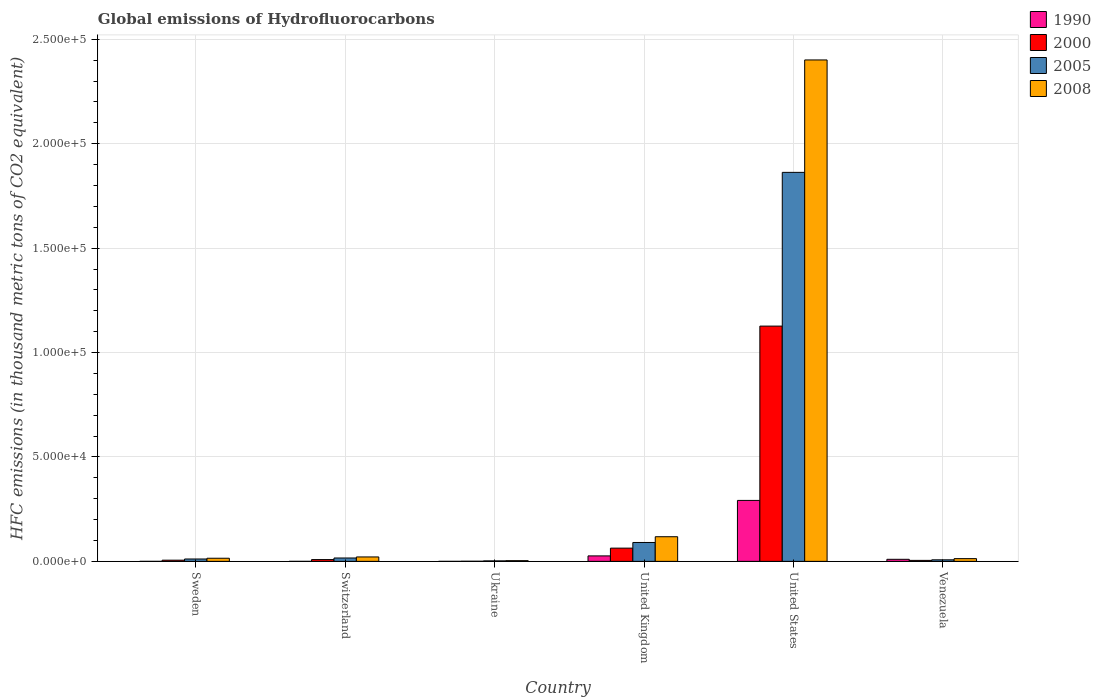How many different coloured bars are there?
Provide a short and direct response. 4. How many bars are there on the 3rd tick from the left?
Make the answer very short. 4. What is the global emissions of Hydrofluorocarbons in 2000 in United Kingdom?
Keep it short and to the point. 6332.5. Across all countries, what is the maximum global emissions of Hydrofluorocarbons in 2005?
Offer a very short reply. 1.86e+05. Across all countries, what is the minimum global emissions of Hydrofluorocarbons in 2008?
Offer a terse response. 333.5. In which country was the global emissions of Hydrofluorocarbons in 2000 minimum?
Offer a terse response. Ukraine. What is the total global emissions of Hydrofluorocarbons in 2008 in the graph?
Your response must be concise. 2.57e+05. What is the difference between the global emissions of Hydrofluorocarbons in 2005 in Ukraine and that in United States?
Make the answer very short. -1.86e+05. What is the difference between the global emissions of Hydrofluorocarbons in 2005 in United States and the global emissions of Hydrofluorocarbons in 1990 in Sweden?
Your response must be concise. 1.86e+05. What is the average global emissions of Hydrofluorocarbons in 2000 per country?
Your answer should be compact. 2.02e+04. What is the difference between the global emissions of Hydrofluorocarbons of/in 2000 and global emissions of Hydrofluorocarbons of/in 2005 in Ukraine?
Your answer should be compact. -172.5. What is the ratio of the global emissions of Hydrofluorocarbons in 2008 in Sweden to that in Switzerland?
Offer a terse response. 0.71. Is the global emissions of Hydrofluorocarbons in 2008 in Switzerland less than that in United Kingdom?
Your answer should be compact. Yes. Is the difference between the global emissions of Hydrofluorocarbons in 2000 in Switzerland and Ukraine greater than the difference between the global emissions of Hydrofluorocarbons in 2005 in Switzerland and Ukraine?
Make the answer very short. No. What is the difference between the highest and the second highest global emissions of Hydrofluorocarbons in 2008?
Your response must be concise. 9679.6. What is the difference between the highest and the lowest global emissions of Hydrofluorocarbons in 1990?
Your answer should be compact. 2.92e+04. In how many countries, is the global emissions of Hydrofluorocarbons in 1990 greater than the average global emissions of Hydrofluorocarbons in 1990 taken over all countries?
Your answer should be very brief. 1. What does the 2nd bar from the left in United Kingdom represents?
Provide a succinct answer. 2000. Is it the case that in every country, the sum of the global emissions of Hydrofluorocarbons in 2000 and global emissions of Hydrofluorocarbons in 2008 is greater than the global emissions of Hydrofluorocarbons in 2005?
Offer a very short reply. Yes. How many countries are there in the graph?
Give a very brief answer. 6. Are the values on the major ticks of Y-axis written in scientific E-notation?
Provide a succinct answer. Yes. Does the graph contain grids?
Offer a very short reply. Yes. Where does the legend appear in the graph?
Offer a very short reply. Top right. How many legend labels are there?
Ensure brevity in your answer.  4. What is the title of the graph?
Provide a succinct answer. Global emissions of Hydrofluorocarbons. What is the label or title of the X-axis?
Ensure brevity in your answer.  Country. What is the label or title of the Y-axis?
Your response must be concise. HFC emissions (in thousand metric tons of CO2 equivalent). What is the HFC emissions (in thousand metric tons of CO2 equivalent) in 2000 in Sweden?
Provide a succinct answer. 568.8. What is the HFC emissions (in thousand metric tons of CO2 equivalent) of 2005 in Sweden?
Offer a terse response. 1131.9. What is the HFC emissions (in thousand metric tons of CO2 equivalent) in 2008 in Sweden?
Your answer should be compact. 1498. What is the HFC emissions (in thousand metric tons of CO2 equivalent) of 2000 in Switzerland?
Provide a succinct answer. 848.2. What is the HFC emissions (in thousand metric tons of CO2 equivalent) of 2005 in Switzerland?
Keep it short and to the point. 1613.8. What is the HFC emissions (in thousand metric tons of CO2 equivalent) in 2008 in Switzerland?
Give a very brief answer. 2116.4. What is the HFC emissions (in thousand metric tons of CO2 equivalent) in 1990 in Ukraine?
Your answer should be compact. 0.1. What is the HFC emissions (in thousand metric tons of CO2 equivalent) in 2000 in Ukraine?
Your response must be concise. 54.7. What is the HFC emissions (in thousand metric tons of CO2 equivalent) in 2005 in Ukraine?
Give a very brief answer. 227.2. What is the HFC emissions (in thousand metric tons of CO2 equivalent) in 2008 in Ukraine?
Ensure brevity in your answer.  333.5. What is the HFC emissions (in thousand metric tons of CO2 equivalent) of 1990 in United Kingdom?
Your answer should be compact. 2617.8. What is the HFC emissions (in thousand metric tons of CO2 equivalent) of 2000 in United Kingdom?
Make the answer very short. 6332.5. What is the HFC emissions (in thousand metric tons of CO2 equivalent) of 2005 in United Kingdom?
Offer a very short reply. 9043.4. What is the HFC emissions (in thousand metric tons of CO2 equivalent) in 2008 in United Kingdom?
Provide a short and direct response. 1.18e+04. What is the HFC emissions (in thousand metric tons of CO2 equivalent) in 1990 in United States?
Offer a terse response. 2.92e+04. What is the HFC emissions (in thousand metric tons of CO2 equivalent) of 2000 in United States?
Provide a short and direct response. 1.13e+05. What is the HFC emissions (in thousand metric tons of CO2 equivalent) in 2005 in United States?
Your answer should be very brief. 1.86e+05. What is the HFC emissions (in thousand metric tons of CO2 equivalent) of 2008 in United States?
Your answer should be very brief. 2.40e+05. What is the HFC emissions (in thousand metric tons of CO2 equivalent) of 1990 in Venezuela?
Offer a very short reply. 989.6. What is the HFC emissions (in thousand metric tons of CO2 equivalent) of 2000 in Venezuela?
Provide a succinct answer. 468.5. What is the HFC emissions (in thousand metric tons of CO2 equivalent) in 2005 in Venezuela?
Provide a short and direct response. 738.4. What is the HFC emissions (in thousand metric tons of CO2 equivalent) of 2008 in Venezuela?
Keep it short and to the point. 1307.1. Across all countries, what is the maximum HFC emissions (in thousand metric tons of CO2 equivalent) of 1990?
Keep it short and to the point. 2.92e+04. Across all countries, what is the maximum HFC emissions (in thousand metric tons of CO2 equivalent) in 2000?
Offer a terse response. 1.13e+05. Across all countries, what is the maximum HFC emissions (in thousand metric tons of CO2 equivalent) in 2005?
Your answer should be very brief. 1.86e+05. Across all countries, what is the maximum HFC emissions (in thousand metric tons of CO2 equivalent) in 2008?
Your answer should be very brief. 2.40e+05. Across all countries, what is the minimum HFC emissions (in thousand metric tons of CO2 equivalent) of 2000?
Ensure brevity in your answer.  54.7. Across all countries, what is the minimum HFC emissions (in thousand metric tons of CO2 equivalent) of 2005?
Provide a short and direct response. 227.2. Across all countries, what is the minimum HFC emissions (in thousand metric tons of CO2 equivalent) in 2008?
Offer a terse response. 333.5. What is the total HFC emissions (in thousand metric tons of CO2 equivalent) in 1990 in the graph?
Keep it short and to the point. 3.28e+04. What is the total HFC emissions (in thousand metric tons of CO2 equivalent) in 2000 in the graph?
Keep it short and to the point. 1.21e+05. What is the total HFC emissions (in thousand metric tons of CO2 equivalent) in 2005 in the graph?
Ensure brevity in your answer.  1.99e+05. What is the total HFC emissions (in thousand metric tons of CO2 equivalent) of 2008 in the graph?
Your answer should be compact. 2.57e+05. What is the difference between the HFC emissions (in thousand metric tons of CO2 equivalent) in 1990 in Sweden and that in Switzerland?
Keep it short and to the point. -0.1. What is the difference between the HFC emissions (in thousand metric tons of CO2 equivalent) in 2000 in Sweden and that in Switzerland?
Your answer should be very brief. -279.4. What is the difference between the HFC emissions (in thousand metric tons of CO2 equivalent) in 2005 in Sweden and that in Switzerland?
Offer a terse response. -481.9. What is the difference between the HFC emissions (in thousand metric tons of CO2 equivalent) of 2008 in Sweden and that in Switzerland?
Give a very brief answer. -618.4. What is the difference between the HFC emissions (in thousand metric tons of CO2 equivalent) of 2000 in Sweden and that in Ukraine?
Your response must be concise. 514.1. What is the difference between the HFC emissions (in thousand metric tons of CO2 equivalent) in 2005 in Sweden and that in Ukraine?
Ensure brevity in your answer.  904.7. What is the difference between the HFC emissions (in thousand metric tons of CO2 equivalent) of 2008 in Sweden and that in Ukraine?
Your response must be concise. 1164.5. What is the difference between the HFC emissions (in thousand metric tons of CO2 equivalent) in 1990 in Sweden and that in United Kingdom?
Provide a succinct answer. -2617.6. What is the difference between the HFC emissions (in thousand metric tons of CO2 equivalent) of 2000 in Sweden and that in United Kingdom?
Offer a very short reply. -5763.7. What is the difference between the HFC emissions (in thousand metric tons of CO2 equivalent) in 2005 in Sweden and that in United Kingdom?
Your answer should be compact. -7911.5. What is the difference between the HFC emissions (in thousand metric tons of CO2 equivalent) of 2008 in Sweden and that in United Kingdom?
Make the answer very short. -1.03e+04. What is the difference between the HFC emissions (in thousand metric tons of CO2 equivalent) of 1990 in Sweden and that in United States?
Provide a short and direct response. -2.92e+04. What is the difference between the HFC emissions (in thousand metric tons of CO2 equivalent) of 2000 in Sweden and that in United States?
Make the answer very short. -1.12e+05. What is the difference between the HFC emissions (in thousand metric tons of CO2 equivalent) in 2005 in Sweden and that in United States?
Your answer should be very brief. -1.85e+05. What is the difference between the HFC emissions (in thousand metric tons of CO2 equivalent) of 2008 in Sweden and that in United States?
Your answer should be very brief. -2.39e+05. What is the difference between the HFC emissions (in thousand metric tons of CO2 equivalent) in 1990 in Sweden and that in Venezuela?
Your answer should be compact. -989.4. What is the difference between the HFC emissions (in thousand metric tons of CO2 equivalent) of 2000 in Sweden and that in Venezuela?
Give a very brief answer. 100.3. What is the difference between the HFC emissions (in thousand metric tons of CO2 equivalent) in 2005 in Sweden and that in Venezuela?
Offer a very short reply. 393.5. What is the difference between the HFC emissions (in thousand metric tons of CO2 equivalent) in 2008 in Sweden and that in Venezuela?
Ensure brevity in your answer.  190.9. What is the difference between the HFC emissions (in thousand metric tons of CO2 equivalent) of 2000 in Switzerland and that in Ukraine?
Provide a short and direct response. 793.5. What is the difference between the HFC emissions (in thousand metric tons of CO2 equivalent) in 2005 in Switzerland and that in Ukraine?
Your response must be concise. 1386.6. What is the difference between the HFC emissions (in thousand metric tons of CO2 equivalent) of 2008 in Switzerland and that in Ukraine?
Provide a short and direct response. 1782.9. What is the difference between the HFC emissions (in thousand metric tons of CO2 equivalent) in 1990 in Switzerland and that in United Kingdom?
Provide a short and direct response. -2617.5. What is the difference between the HFC emissions (in thousand metric tons of CO2 equivalent) in 2000 in Switzerland and that in United Kingdom?
Give a very brief answer. -5484.3. What is the difference between the HFC emissions (in thousand metric tons of CO2 equivalent) of 2005 in Switzerland and that in United Kingdom?
Give a very brief answer. -7429.6. What is the difference between the HFC emissions (in thousand metric tons of CO2 equivalent) in 2008 in Switzerland and that in United Kingdom?
Offer a very short reply. -9679.6. What is the difference between the HFC emissions (in thousand metric tons of CO2 equivalent) of 1990 in Switzerland and that in United States?
Ensure brevity in your answer.  -2.92e+04. What is the difference between the HFC emissions (in thousand metric tons of CO2 equivalent) in 2000 in Switzerland and that in United States?
Offer a very short reply. -1.12e+05. What is the difference between the HFC emissions (in thousand metric tons of CO2 equivalent) of 2005 in Switzerland and that in United States?
Your response must be concise. -1.85e+05. What is the difference between the HFC emissions (in thousand metric tons of CO2 equivalent) in 2008 in Switzerland and that in United States?
Your answer should be very brief. -2.38e+05. What is the difference between the HFC emissions (in thousand metric tons of CO2 equivalent) of 1990 in Switzerland and that in Venezuela?
Provide a succinct answer. -989.3. What is the difference between the HFC emissions (in thousand metric tons of CO2 equivalent) in 2000 in Switzerland and that in Venezuela?
Your answer should be compact. 379.7. What is the difference between the HFC emissions (in thousand metric tons of CO2 equivalent) in 2005 in Switzerland and that in Venezuela?
Give a very brief answer. 875.4. What is the difference between the HFC emissions (in thousand metric tons of CO2 equivalent) of 2008 in Switzerland and that in Venezuela?
Keep it short and to the point. 809.3. What is the difference between the HFC emissions (in thousand metric tons of CO2 equivalent) of 1990 in Ukraine and that in United Kingdom?
Provide a short and direct response. -2617.7. What is the difference between the HFC emissions (in thousand metric tons of CO2 equivalent) in 2000 in Ukraine and that in United Kingdom?
Keep it short and to the point. -6277.8. What is the difference between the HFC emissions (in thousand metric tons of CO2 equivalent) in 2005 in Ukraine and that in United Kingdom?
Give a very brief answer. -8816.2. What is the difference between the HFC emissions (in thousand metric tons of CO2 equivalent) of 2008 in Ukraine and that in United Kingdom?
Ensure brevity in your answer.  -1.15e+04. What is the difference between the HFC emissions (in thousand metric tons of CO2 equivalent) in 1990 in Ukraine and that in United States?
Offer a terse response. -2.92e+04. What is the difference between the HFC emissions (in thousand metric tons of CO2 equivalent) in 2000 in Ukraine and that in United States?
Your response must be concise. -1.13e+05. What is the difference between the HFC emissions (in thousand metric tons of CO2 equivalent) of 2005 in Ukraine and that in United States?
Offer a very short reply. -1.86e+05. What is the difference between the HFC emissions (in thousand metric tons of CO2 equivalent) of 2008 in Ukraine and that in United States?
Offer a terse response. -2.40e+05. What is the difference between the HFC emissions (in thousand metric tons of CO2 equivalent) in 1990 in Ukraine and that in Venezuela?
Ensure brevity in your answer.  -989.5. What is the difference between the HFC emissions (in thousand metric tons of CO2 equivalent) in 2000 in Ukraine and that in Venezuela?
Offer a terse response. -413.8. What is the difference between the HFC emissions (in thousand metric tons of CO2 equivalent) of 2005 in Ukraine and that in Venezuela?
Ensure brevity in your answer.  -511.2. What is the difference between the HFC emissions (in thousand metric tons of CO2 equivalent) in 2008 in Ukraine and that in Venezuela?
Make the answer very short. -973.6. What is the difference between the HFC emissions (in thousand metric tons of CO2 equivalent) in 1990 in United Kingdom and that in United States?
Offer a very short reply. -2.66e+04. What is the difference between the HFC emissions (in thousand metric tons of CO2 equivalent) of 2000 in United Kingdom and that in United States?
Make the answer very short. -1.06e+05. What is the difference between the HFC emissions (in thousand metric tons of CO2 equivalent) of 2005 in United Kingdom and that in United States?
Ensure brevity in your answer.  -1.77e+05. What is the difference between the HFC emissions (in thousand metric tons of CO2 equivalent) of 2008 in United Kingdom and that in United States?
Your answer should be compact. -2.28e+05. What is the difference between the HFC emissions (in thousand metric tons of CO2 equivalent) in 1990 in United Kingdom and that in Venezuela?
Ensure brevity in your answer.  1628.2. What is the difference between the HFC emissions (in thousand metric tons of CO2 equivalent) in 2000 in United Kingdom and that in Venezuela?
Ensure brevity in your answer.  5864. What is the difference between the HFC emissions (in thousand metric tons of CO2 equivalent) in 2005 in United Kingdom and that in Venezuela?
Your answer should be very brief. 8305. What is the difference between the HFC emissions (in thousand metric tons of CO2 equivalent) in 2008 in United Kingdom and that in Venezuela?
Your response must be concise. 1.05e+04. What is the difference between the HFC emissions (in thousand metric tons of CO2 equivalent) of 1990 in United States and that in Venezuela?
Offer a terse response. 2.82e+04. What is the difference between the HFC emissions (in thousand metric tons of CO2 equivalent) in 2000 in United States and that in Venezuela?
Your answer should be very brief. 1.12e+05. What is the difference between the HFC emissions (in thousand metric tons of CO2 equivalent) in 2005 in United States and that in Venezuela?
Provide a short and direct response. 1.86e+05. What is the difference between the HFC emissions (in thousand metric tons of CO2 equivalent) of 2008 in United States and that in Venezuela?
Offer a very short reply. 2.39e+05. What is the difference between the HFC emissions (in thousand metric tons of CO2 equivalent) in 1990 in Sweden and the HFC emissions (in thousand metric tons of CO2 equivalent) in 2000 in Switzerland?
Offer a terse response. -848. What is the difference between the HFC emissions (in thousand metric tons of CO2 equivalent) of 1990 in Sweden and the HFC emissions (in thousand metric tons of CO2 equivalent) of 2005 in Switzerland?
Ensure brevity in your answer.  -1613.6. What is the difference between the HFC emissions (in thousand metric tons of CO2 equivalent) of 1990 in Sweden and the HFC emissions (in thousand metric tons of CO2 equivalent) of 2008 in Switzerland?
Make the answer very short. -2116.2. What is the difference between the HFC emissions (in thousand metric tons of CO2 equivalent) of 2000 in Sweden and the HFC emissions (in thousand metric tons of CO2 equivalent) of 2005 in Switzerland?
Your response must be concise. -1045. What is the difference between the HFC emissions (in thousand metric tons of CO2 equivalent) of 2000 in Sweden and the HFC emissions (in thousand metric tons of CO2 equivalent) of 2008 in Switzerland?
Provide a succinct answer. -1547.6. What is the difference between the HFC emissions (in thousand metric tons of CO2 equivalent) in 2005 in Sweden and the HFC emissions (in thousand metric tons of CO2 equivalent) in 2008 in Switzerland?
Your answer should be very brief. -984.5. What is the difference between the HFC emissions (in thousand metric tons of CO2 equivalent) in 1990 in Sweden and the HFC emissions (in thousand metric tons of CO2 equivalent) in 2000 in Ukraine?
Offer a terse response. -54.5. What is the difference between the HFC emissions (in thousand metric tons of CO2 equivalent) of 1990 in Sweden and the HFC emissions (in thousand metric tons of CO2 equivalent) of 2005 in Ukraine?
Make the answer very short. -227. What is the difference between the HFC emissions (in thousand metric tons of CO2 equivalent) in 1990 in Sweden and the HFC emissions (in thousand metric tons of CO2 equivalent) in 2008 in Ukraine?
Offer a very short reply. -333.3. What is the difference between the HFC emissions (in thousand metric tons of CO2 equivalent) in 2000 in Sweden and the HFC emissions (in thousand metric tons of CO2 equivalent) in 2005 in Ukraine?
Offer a very short reply. 341.6. What is the difference between the HFC emissions (in thousand metric tons of CO2 equivalent) of 2000 in Sweden and the HFC emissions (in thousand metric tons of CO2 equivalent) of 2008 in Ukraine?
Offer a terse response. 235.3. What is the difference between the HFC emissions (in thousand metric tons of CO2 equivalent) in 2005 in Sweden and the HFC emissions (in thousand metric tons of CO2 equivalent) in 2008 in Ukraine?
Keep it short and to the point. 798.4. What is the difference between the HFC emissions (in thousand metric tons of CO2 equivalent) of 1990 in Sweden and the HFC emissions (in thousand metric tons of CO2 equivalent) of 2000 in United Kingdom?
Give a very brief answer. -6332.3. What is the difference between the HFC emissions (in thousand metric tons of CO2 equivalent) of 1990 in Sweden and the HFC emissions (in thousand metric tons of CO2 equivalent) of 2005 in United Kingdom?
Keep it short and to the point. -9043.2. What is the difference between the HFC emissions (in thousand metric tons of CO2 equivalent) in 1990 in Sweden and the HFC emissions (in thousand metric tons of CO2 equivalent) in 2008 in United Kingdom?
Your response must be concise. -1.18e+04. What is the difference between the HFC emissions (in thousand metric tons of CO2 equivalent) in 2000 in Sweden and the HFC emissions (in thousand metric tons of CO2 equivalent) in 2005 in United Kingdom?
Provide a short and direct response. -8474.6. What is the difference between the HFC emissions (in thousand metric tons of CO2 equivalent) in 2000 in Sweden and the HFC emissions (in thousand metric tons of CO2 equivalent) in 2008 in United Kingdom?
Make the answer very short. -1.12e+04. What is the difference between the HFC emissions (in thousand metric tons of CO2 equivalent) of 2005 in Sweden and the HFC emissions (in thousand metric tons of CO2 equivalent) of 2008 in United Kingdom?
Keep it short and to the point. -1.07e+04. What is the difference between the HFC emissions (in thousand metric tons of CO2 equivalent) in 1990 in Sweden and the HFC emissions (in thousand metric tons of CO2 equivalent) in 2000 in United States?
Your answer should be very brief. -1.13e+05. What is the difference between the HFC emissions (in thousand metric tons of CO2 equivalent) of 1990 in Sweden and the HFC emissions (in thousand metric tons of CO2 equivalent) of 2005 in United States?
Ensure brevity in your answer.  -1.86e+05. What is the difference between the HFC emissions (in thousand metric tons of CO2 equivalent) in 1990 in Sweden and the HFC emissions (in thousand metric tons of CO2 equivalent) in 2008 in United States?
Provide a short and direct response. -2.40e+05. What is the difference between the HFC emissions (in thousand metric tons of CO2 equivalent) of 2000 in Sweden and the HFC emissions (in thousand metric tons of CO2 equivalent) of 2005 in United States?
Keep it short and to the point. -1.86e+05. What is the difference between the HFC emissions (in thousand metric tons of CO2 equivalent) of 2000 in Sweden and the HFC emissions (in thousand metric tons of CO2 equivalent) of 2008 in United States?
Your answer should be very brief. -2.40e+05. What is the difference between the HFC emissions (in thousand metric tons of CO2 equivalent) in 2005 in Sweden and the HFC emissions (in thousand metric tons of CO2 equivalent) in 2008 in United States?
Provide a succinct answer. -2.39e+05. What is the difference between the HFC emissions (in thousand metric tons of CO2 equivalent) in 1990 in Sweden and the HFC emissions (in thousand metric tons of CO2 equivalent) in 2000 in Venezuela?
Give a very brief answer. -468.3. What is the difference between the HFC emissions (in thousand metric tons of CO2 equivalent) of 1990 in Sweden and the HFC emissions (in thousand metric tons of CO2 equivalent) of 2005 in Venezuela?
Give a very brief answer. -738.2. What is the difference between the HFC emissions (in thousand metric tons of CO2 equivalent) in 1990 in Sweden and the HFC emissions (in thousand metric tons of CO2 equivalent) in 2008 in Venezuela?
Your answer should be compact. -1306.9. What is the difference between the HFC emissions (in thousand metric tons of CO2 equivalent) of 2000 in Sweden and the HFC emissions (in thousand metric tons of CO2 equivalent) of 2005 in Venezuela?
Your answer should be compact. -169.6. What is the difference between the HFC emissions (in thousand metric tons of CO2 equivalent) in 2000 in Sweden and the HFC emissions (in thousand metric tons of CO2 equivalent) in 2008 in Venezuela?
Keep it short and to the point. -738.3. What is the difference between the HFC emissions (in thousand metric tons of CO2 equivalent) in 2005 in Sweden and the HFC emissions (in thousand metric tons of CO2 equivalent) in 2008 in Venezuela?
Ensure brevity in your answer.  -175.2. What is the difference between the HFC emissions (in thousand metric tons of CO2 equivalent) in 1990 in Switzerland and the HFC emissions (in thousand metric tons of CO2 equivalent) in 2000 in Ukraine?
Offer a terse response. -54.4. What is the difference between the HFC emissions (in thousand metric tons of CO2 equivalent) of 1990 in Switzerland and the HFC emissions (in thousand metric tons of CO2 equivalent) of 2005 in Ukraine?
Your answer should be compact. -226.9. What is the difference between the HFC emissions (in thousand metric tons of CO2 equivalent) of 1990 in Switzerland and the HFC emissions (in thousand metric tons of CO2 equivalent) of 2008 in Ukraine?
Give a very brief answer. -333.2. What is the difference between the HFC emissions (in thousand metric tons of CO2 equivalent) in 2000 in Switzerland and the HFC emissions (in thousand metric tons of CO2 equivalent) in 2005 in Ukraine?
Provide a succinct answer. 621. What is the difference between the HFC emissions (in thousand metric tons of CO2 equivalent) of 2000 in Switzerland and the HFC emissions (in thousand metric tons of CO2 equivalent) of 2008 in Ukraine?
Give a very brief answer. 514.7. What is the difference between the HFC emissions (in thousand metric tons of CO2 equivalent) in 2005 in Switzerland and the HFC emissions (in thousand metric tons of CO2 equivalent) in 2008 in Ukraine?
Your answer should be compact. 1280.3. What is the difference between the HFC emissions (in thousand metric tons of CO2 equivalent) of 1990 in Switzerland and the HFC emissions (in thousand metric tons of CO2 equivalent) of 2000 in United Kingdom?
Provide a succinct answer. -6332.2. What is the difference between the HFC emissions (in thousand metric tons of CO2 equivalent) of 1990 in Switzerland and the HFC emissions (in thousand metric tons of CO2 equivalent) of 2005 in United Kingdom?
Provide a succinct answer. -9043.1. What is the difference between the HFC emissions (in thousand metric tons of CO2 equivalent) in 1990 in Switzerland and the HFC emissions (in thousand metric tons of CO2 equivalent) in 2008 in United Kingdom?
Provide a succinct answer. -1.18e+04. What is the difference between the HFC emissions (in thousand metric tons of CO2 equivalent) in 2000 in Switzerland and the HFC emissions (in thousand metric tons of CO2 equivalent) in 2005 in United Kingdom?
Ensure brevity in your answer.  -8195.2. What is the difference between the HFC emissions (in thousand metric tons of CO2 equivalent) of 2000 in Switzerland and the HFC emissions (in thousand metric tons of CO2 equivalent) of 2008 in United Kingdom?
Your answer should be very brief. -1.09e+04. What is the difference between the HFC emissions (in thousand metric tons of CO2 equivalent) in 2005 in Switzerland and the HFC emissions (in thousand metric tons of CO2 equivalent) in 2008 in United Kingdom?
Your response must be concise. -1.02e+04. What is the difference between the HFC emissions (in thousand metric tons of CO2 equivalent) of 1990 in Switzerland and the HFC emissions (in thousand metric tons of CO2 equivalent) of 2000 in United States?
Make the answer very short. -1.13e+05. What is the difference between the HFC emissions (in thousand metric tons of CO2 equivalent) of 1990 in Switzerland and the HFC emissions (in thousand metric tons of CO2 equivalent) of 2005 in United States?
Provide a succinct answer. -1.86e+05. What is the difference between the HFC emissions (in thousand metric tons of CO2 equivalent) of 1990 in Switzerland and the HFC emissions (in thousand metric tons of CO2 equivalent) of 2008 in United States?
Offer a terse response. -2.40e+05. What is the difference between the HFC emissions (in thousand metric tons of CO2 equivalent) of 2000 in Switzerland and the HFC emissions (in thousand metric tons of CO2 equivalent) of 2005 in United States?
Offer a terse response. -1.85e+05. What is the difference between the HFC emissions (in thousand metric tons of CO2 equivalent) of 2000 in Switzerland and the HFC emissions (in thousand metric tons of CO2 equivalent) of 2008 in United States?
Your answer should be very brief. -2.39e+05. What is the difference between the HFC emissions (in thousand metric tons of CO2 equivalent) of 2005 in Switzerland and the HFC emissions (in thousand metric tons of CO2 equivalent) of 2008 in United States?
Provide a succinct answer. -2.39e+05. What is the difference between the HFC emissions (in thousand metric tons of CO2 equivalent) of 1990 in Switzerland and the HFC emissions (in thousand metric tons of CO2 equivalent) of 2000 in Venezuela?
Provide a short and direct response. -468.2. What is the difference between the HFC emissions (in thousand metric tons of CO2 equivalent) in 1990 in Switzerland and the HFC emissions (in thousand metric tons of CO2 equivalent) in 2005 in Venezuela?
Make the answer very short. -738.1. What is the difference between the HFC emissions (in thousand metric tons of CO2 equivalent) in 1990 in Switzerland and the HFC emissions (in thousand metric tons of CO2 equivalent) in 2008 in Venezuela?
Your answer should be compact. -1306.8. What is the difference between the HFC emissions (in thousand metric tons of CO2 equivalent) of 2000 in Switzerland and the HFC emissions (in thousand metric tons of CO2 equivalent) of 2005 in Venezuela?
Make the answer very short. 109.8. What is the difference between the HFC emissions (in thousand metric tons of CO2 equivalent) in 2000 in Switzerland and the HFC emissions (in thousand metric tons of CO2 equivalent) in 2008 in Venezuela?
Your answer should be compact. -458.9. What is the difference between the HFC emissions (in thousand metric tons of CO2 equivalent) of 2005 in Switzerland and the HFC emissions (in thousand metric tons of CO2 equivalent) of 2008 in Venezuela?
Ensure brevity in your answer.  306.7. What is the difference between the HFC emissions (in thousand metric tons of CO2 equivalent) in 1990 in Ukraine and the HFC emissions (in thousand metric tons of CO2 equivalent) in 2000 in United Kingdom?
Your answer should be compact. -6332.4. What is the difference between the HFC emissions (in thousand metric tons of CO2 equivalent) of 1990 in Ukraine and the HFC emissions (in thousand metric tons of CO2 equivalent) of 2005 in United Kingdom?
Your response must be concise. -9043.3. What is the difference between the HFC emissions (in thousand metric tons of CO2 equivalent) of 1990 in Ukraine and the HFC emissions (in thousand metric tons of CO2 equivalent) of 2008 in United Kingdom?
Provide a short and direct response. -1.18e+04. What is the difference between the HFC emissions (in thousand metric tons of CO2 equivalent) in 2000 in Ukraine and the HFC emissions (in thousand metric tons of CO2 equivalent) in 2005 in United Kingdom?
Your answer should be very brief. -8988.7. What is the difference between the HFC emissions (in thousand metric tons of CO2 equivalent) of 2000 in Ukraine and the HFC emissions (in thousand metric tons of CO2 equivalent) of 2008 in United Kingdom?
Your answer should be very brief. -1.17e+04. What is the difference between the HFC emissions (in thousand metric tons of CO2 equivalent) of 2005 in Ukraine and the HFC emissions (in thousand metric tons of CO2 equivalent) of 2008 in United Kingdom?
Make the answer very short. -1.16e+04. What is the difference between the HFC emissions (in thousand metric tons of CO2 equivalent) of 1990 in Ukraine and the HFC emissions (in thousand metric tons of CO2 equivalent) of 2000 in United States?
Your answer should be compact. -1.13e+05. What is the difference between the HFC emissions (in thousand metric tons of CO2 equivalent) of 1990 in Ukraine and the HFC emissions (in thousand metric tons of CO2 equivalent) of 2005 in United States?
Your response must be concise. -1.86e+05. What is the difference between the HFC emissions (in thousand metric tons of CO2 equivalent) in 1990 in Ukraine and the HFC emissions (in thousand metric tons of CO2 equivalent) in 2008 in United States?
Your response must be concise. -2.40e+05. What is the difference between the HFC emissions (in thousand metric tons of CO2 equivalent) in 2000 in Ukraine and the HFC emissions (in thousand metric tons of CO2 equivalent) in 2005 in United States?
Offer a terse response. -1.86e+05. What is the difference between the HFC emissions (in thousand metric tons of CO2 equivalent) in 2000 in Ukraine and the HFC emissions (in thousand metric tons of CO2 equivalent) in 2008 in United States?
Make the answer very short. -2.40e+05. What is the difference between the HFC emissions (in thousand metric tons of CO2 equivalent) in 2005 in Ukraine and the HFC emissions (in thousand metric tons of CO2 equivalent) in 2008 in United States?
Your answer should be compact. -2.40e+05. What is the difference between the HFC emissions (in thousand metric tons of CO2 equivalent) of 1990 in Ukraine and the HFC emissions (in thousand metric tons of CO2 equivalent) of 2000 in Venezuela?
Your answer should be compact. -468.4. What is the difference between the HFC emissions (in thousand metric tons of CO2 equivalent) in 1990 in Ukraine and the HFC emissions (in thousand metric tons of CO2 equivalent) in 2005 in Venezuela?
Keep it short and to the point. -738.3. What is the difference between the HFC emissions (in thousand metric tons of CO2 equivalent) in 1990 in Ukraine and the HFC emissions (in thousand metric tons of CO2 equivalent) in 2008 in Venezuela?
Offer a terse response. -1307. What is the difference between the HFC emissions (in thousand metric tons of CO2 equivalent) in 2000 in Ukraine and the HFC emissions (in thousand metric tons of CO2 equivalent) in 2005 in Venezuela?
Provide a succinct answer. -683.7. What is the difference between the HFC emissions (in thousand metric tons of CO2 equivalent) in 2000 in Ukraine and the HFC emissions (in thousand metric tons of CO2 equivalent) in 2008 in Venezuela?
Give a very brief answer. -1252.4. What is the difference between the HFC emissions (in thousand metric tons of CO2 equivalent) in 2005 in Ukraine and the HFC emissions (in thousand metric tons of CO2 equivalent) in 2008 in Venezuela?
Provide a short and direct response. -1079.9. What is the difference between the HFC emissions (in thousand metric tons of CO2 equivalent) of 1990 in United Kingdom and the HFC emissions (in thousand metric tons of CO2 equivalent) of 2000 in United States?
Offer a very short reply. -1.10e+05. What is the difference between the HFC emissions (in thousand metric tons of CO2 equivalent) of 1990 in United Kingdom and the HFC emissions (in thousand metric tons of CO2 equivalent) of 2005 in United States?
Offer a terse response. -1.84e+05. What is the difference between the HFC emissions (in thousand metric tons of CO2 equivalent) of 1990 in United Kingdom and the HFC emissions (in thousand metric tons of CO2 equivalent) of 2008 in United States?
Your answer should be very brief. -2.38e+05. What is the difference between the HFC emissions (in thousand metric tons of CO2 equivalent) in 2000 in United Kingdom and the HFC emissions (in thousand metric tons of CO2 equivalent) in 2005 in United States?
Your answer should be compact. -1.80e+05. What is the difference between the HFC emissions (in thousand metric tons of CO2 equivalent) of 2000 in United Kingdom and the HFC emissions (in thousand metric tons of CO2 equivalent) of 2008 in United States?
Offer a terse response. -2.34e+05. What is the difference between the HFC emissions (in thousand metric tons of CO2 equivalent) in 2005 in United Kingdom and the HFC emissions (in thousand metric tons of CO2 equivalent) in 2008 in United States?
Provide a short and direct response. -2.31e+05. What is the difference between the HFC emissions (in thousand metric tons of CO2 equivalent) of 1990 in United Kingdom and the HFC emissions (in thousand metric tons of CO2 equivalent) of 2000 in Venezuela?
Keep it short and to the point. 2149.3. What is the difference between the HFC emissions (in thousand metric tons of CO2 equivalent) in 1990 in United Kingdom and the HFC emissions (in thousand metric tons of CO2 equivalent) in 2005 in Venezuela?
Keep it short and to the point. 1879.4. What is the difference between the HFC emissions (in thousand metric tons of CO2 equivalent) in 1990 in United Kingdom and the HFC emissions (in thousand metric tons of CO2 equivalent) in 2008 in Venezuela?
Provide a short and direct response. 1310.7. What is the difference between the HFC emissions (in thousand metric tons of CO2 equivalent) of 2000 in United Kingdom and the HFC emissions (in thousand metric tons of CO2 equivalent) of 2005 in Venezuela?
Ensure brevity in your answer.  5594.1. What is the difference between the HFC emissions (in thousand metric tons of CO2 equivalent) in 2000 in United Kingdom and the HFC emissions (in thousand metric tons of CO2 equivalent) in 2008 in Venezuela?
Keep it short and to the point. 5025.4. What is the difference between the HFC emissions (in thousand metric tons of CO2 equivalent) in 2005 in United Kingdom and the HFC emissions (in thousand metric tons of CO2 equivalent) in 2008 in Venezuela?
Make the answer very short. 7736.3. What is the difference between the HFC emissions (in thousand metric tons of CO2 equivalent) of 1990 in United States and the HFC emissions (in thousand metric tons of CO2 equivalent) of 2000 in Venezuela?
Offer a terse response. 2.87e+04. What is the difference between the HFC emissions (in thousand metric tons of CO2 equivalent) in 1990 in United States and the HFC emissions (in thousand metric tons of CO2 equivalent) in 2005 in Venezuela?
Ensure brevity in your answer.  2.84e+04. What is the difference between the HFC emissions (in thousand metric tons of CO2 equivalent) in 1990 in United States and the HFC emissions (in thousand metric tons of CO2 equivalent) in 2008 in Venezuela?
Your answer should be very brief. 2.79e+04. What is the difference between the HFC emissions (in thousand metric tons of CO2 equivalent) in 2000 in United States and the HFC emissions (in thousand metric tons of CO2 equivalent) in 2005 in Venezuela?
Your answer should be compact. 1.12e+05. What is the difference between the HFC emissions (in thousand metric tons of CO2 equivalent) in 2000 in United States and the HFC emissions (in thousand metric tons of CO2 equivalent) in 2008 in Venezuela?
Give a very brief answer. 1.11e+05. What is the difference between the HFC emissions (in thousand metric tons of CO2 equivalent) of 2005 in United States and the HFC emissions (in thousand metric tons of CO2 equivalent) of 2008 in Venezuela?
Provide a succinct answer. 1.85e+05. What is the average HFC emissions (in thousand metric tons of CO2 equivalent) in 1990 per country?
Make the answer very short. 5465.63. What is the average HFC emissions (in thousand metric tons of CO2 equivalent) in 2000 per country?
Your response must be concise. 2.02e+04. What is the average HFC emissions (in thousand metric tons of CO2 equivalent) in 2005 per country?
Give a very brief answer. 3.32e+04. What is the average HFC emissions (in thousand metric tons of CO2 equivalent) in 2008 per country?
Keep it short and to the point. 4.29e+04. What is the difference between the HFC emissions (in thousand metric tons of CO2 equivalent) in 1990 and HFC emissions (in thousand metric tons of CO2 equivalent) in 2000 in Sweden?
Ensure brevity in your answer.  -568.6. What is the difference between the HFC emissions (in thousand metric tons of CO2 equivalent) in 1990 and HFC emissions (in thousand metric tons of CO2 equivalent) in 2005 in Sweden?
Make the answer very short. -1131.7. What is the difference between the HFC emissions (in thousand metric tons of CO2 equivalent) in 1990 and HFC emissions (in thousand metric tons of CO2 equivalent) in 2008 in Sweden?
Offer a very short reply. -1497.8. What is the difference between the HFC emissions (in thousand metric tons of CO2 equivalent) in 2000 and HFC emissions (in thousand metric tons of CO2 equivalent) in 2005 in Sweden?
Give a very brief answer. -563.1. What is the difference between the HFC emissions (in thousand metric tons of CO2 equivalent) in 2000 and HFC emissions (in thousand metric tons of CO2 equivalent) in 2008 in Sweden?
Provide a succinct answer. -929.2. What is the difference between the HFC emissions (in thousand metric tons of CO2 equivalent) of 2005 and HFC emissions (in thousand metric tons of CO2 equivalent) of 2008 in Sweden?
Your response must be concise. -366.1. What is the difference between the HFC emissions (in thousand metric tons of CO2 equivalent) of 1990 and HFC emissions (in thousand metric tons of CO2 equivalent) of 2000 in Switzerland?
Your response must be concise. -847.9. What is the difference between the HFC emissions (in thousand metric tons of CO2 equivalent) in 1990 and HFC emissions (in thousand metric tons of CO2 equivalent) in 2005 in Switzerland?
Ensure brevity in your answer.  -1613.5. What is the difference between the HFC emissions (in thousand metric tons of CO2 equivalent) of 1990 and HFC emissions (in thousand metric tons of CO2 equivalent) of 2008 in Switzerland?
Give a very brief answer. -2116.1. What is the difference between the HFC emissions (in thousand metric tons of CO2 equivalent) in 2000 and HFC emissions (in thousand metric tons of CO2 equivalent) in 2005 in Switzerland?
Keep it short and to the point. -765.6. What is the difference between the HFC emissions (in thousand metric tons of CO2 equivalent) in 2000 and HFC emissions (in thousand metric tons of CO2 equivalent) in 2008 in Switzerland?
Offer a very short reply. -1268.2. What is the difference between the HFC emissions (in thousand metric tons of CO2 equivalent) of 2005 and HFC emissions (in thousand metric tons of CO2 equivalent) of 2008 in Switzerland?
Your answer should be very brief. -502.6. What is the difference between the HFC emissions (in thousand metric tons of CO2 equivalent) of 1990 and HFC emissions (in thousand metric tons of CO2 equivalent) of 2000 in Ukraine?
Ensure brevity in your answer.  -54.6. What is the difference between the HFC emissions (in thousand metric tons of CO2 equivalent) in 1990 and HFC emissions (in thousand metric tons of CO2 equivalent) in 2005 in Ukraine?
Your response must be concise. -227.1. What is the difference between the HFC emissions (in thousand metric tons of CO2 equivalent) of 1990 and HFC emissions (in thousand metric tons of CO2 equivalent) of 2008 in Ukraine?
Offer a terse response. -333.4. What is the difference between the HFC emissions (in thousand metric tons of CO2 equivalent) of 2000 and HFC emissions (in thousand metric tons of CO2 equivalent) of 2005 in Ukraine?
Give a very brief answer. -172.5. What is the difference between the HFC emissions (in thousand metric tons of CO2 equivalent) of 2000 and HFC emissions (in thousand metric tons of CO2 equivalent) of 2008 in Ukraine?
Give a very brief answer. -278.8. What is the difference between the HFC emissions (in thousand metric tons of CO2 equivalent) of 2005 and HFC emissions (in thousand metric tons of CO2 equivalent) of 2008 in Ukraine?
Offer a very short reply. -106.3. What is the difference between the HFC emissions (in thousand metric tons of CO2 equivalent) in 1990 and HFC emissions (in thousand metric tons of CO2 equivalent) in 2000 in United Kingdom?
Give a very brief answer. -3714.7. What is the difference between the HFC emissions (in thousand metric tons of CO2 equivalent) in 1990 and HFC emissions (in thousand metric tons of CO2 equivalent) in 2005 in United Kingdom?
Your response must be concise. -6425.6. What is the difference between the HFC emissions (in thousand metric tons of CO2 equivalent) of 1990 and HFC emissions (in thousand metric tons of CO2 equivalent) of 2008 in United Kingdom?
Offer a terse response. -9178.2. What is the difference between the HFC emissions (in thousand metric tons of CO2 equivalent) in 2000 and HFC emissions (in thousand metric tons of CO2 equivalent) in 2005 in United Kingdom?
Provide a succinct answer. -2710.9. What is the difference between the HFC emissions (in thousand metric tons of CO2 equivalent) in 2000 and HFC emissions (in thousand metric tons of CO2 equivalent) in 2008 in United Kingdom?
Keep it short and to the point. -5463.5. What is the difference between the HFC emissions (in thousand metric tons of CO2 equivalent) in 2005 and HFC emissions (in thousand metric tons of CO2 equivalent) in 2008 in United Kingdom?
Make the answer very short. -2752.6. What is the difference between the HFC emissions (in thousand metric tons of CO2 equivalent) in 1990 and HFC emissions (in thousand metric tons of CO2 equivalent) in 2000 in United States?
Offer a very short reply. -8.35e+04. What is the difference between the HFC emissions (in thousand metric tons of CO2 equivalent) in 1990 and HFC emissions (in thousand metric tons of CO2 equivalent) in 2005 in United States?
Give a very brief answer. -1.57e+05. What is the difference between the HFC emissions (in thousand metric tons of CO2 equivalent) of 1990 and HFC emissions (in thousand metric tons of CO2 equivalent) of 2008 in United States?
Offer a terse response. -2.11e+05. What is the difference between the HFC emissions (in thousand metric tons of CO2 equivalent) of 2000 and HFC emissions (in thousand metric tons of CO2 equivalent) of 2005 in United States?
Provide a succinct answer. -7.36e+04. What is the difference between the HFC emissions (in thousand metric tons of CO2 equivalent) in 2000 and HFC emissions (in thousand metric tons of CO2 equivalent) in 2008 in United States?
Give a very brief answer. -1.27e+05. What is the difference between the HFC emissions (in thousand metric tons of CO2 equivalent) of 2005 and HFC emissions (in thousand metric tons of CO2 equivalent) of 2008 in United States?
Offer a terse response. -5.38e+04. What is the difference between the HFC emissions (in thousand metric tons of CO2 equivalent) in 1990 and HFC emissions (in thousand metric tons of CO2 equivalent) in 2000 in Venezuela?
Your answer should be very brief. 521.1. What is the difference between the HFC emissions (in thousand metric tons of CO2 equivalent) in 1990 and HFC emissions (in thousand metric tons of CO2 equivalent) in 2005 in Venezuela?
Offer a terse response. 251.2. What is the difference between the HFC emissions (in thousand metric tons of CO2 equivalent) in 1990 and HFC emissions (in thousand metric tons of CO2 equivalent) in 2008 in Venezuela?
Offer a terse response. -317.5. What is the difference between the HFC emissions (in thousand metric tons of CO2 equivalent) of 2000 and HFC emissions (in thousand metric tons of CO2 equivalent) of 2005 in Venezuela?
Provide a short and direct response. -269.9. What is the difference between the HFC emissions (in thousand metric tons of CO2 equivalent) of 2000 and HFC emissions (in thousand metric tons of CO2 equivalent) of 2008 in Venezuela?
Give a very brief answer. -838.6. What is the difference between the HFC emissions (in thousand metric tons of CO2 equivalent) in 2005 and HFC emissions (in thousand metric tons of CO2 equivalent) in 2008 in Venezuela?
Keep it short and to the point. -568.7. What is the ratio of the HFC emissions (in thousand metric tons of CO2 equivalent) of 2000 in Sweden to that in Switzerland?
Offer a terse response. 0.67. What is the ratio of the HFC emissions (in thousand metric tons of CO2 equivalent) of 2005 in Sweden to that in Switzerland?
Give a very brief answer. 0.7. What is the ratio of the HFC emissions (in thousand metric tons of CO2 equivalent) in 2008 in Sweden to that in Switzerland?
Your response must be concise. 0.71. What is the ratio of the HFC emissions (in thousand metric tons of CO2 equivalent) of 2000 in Sweden to that in Ukraine?
Your response must be concise. 10.4. What is the ratio of the HFC emissions (in thousand metric tons of CO2 equivalent) in 2005 in Sweden to that in Ukraine?
Your answer should be very brief. 4.98. What is the ratio of the HFC emissions (in thousand metric tons of CO2 equivalent) of 2008 in Sweden to that in Ukraine?
Provide a succinct answer. 4.49. What is the ratio of the HFC emissions (in thousand metric tons of CO2 equivalent) of 2000 in Sweden to that in United Kingdom?
Give a very brief answer. 0.09. What is the ratio of the HFC emissions (in thousand metric tons of CO2 equivalent) in 2005 in Sweden to that in United Kingdom?
Keep it short and to the point. 0.13. What is the ratio of the HFC emissions (in thousand metric tons of CO2 equivalent) in 2008 in Sweden to that in United Kingdom?
Ensure brevity in your answer.  0.13. What is the ratio of the HFC emissions (in thousand metric tons of CO2 equivalent) in 1990 in Sweden to that in United States?
Offer a very short reply. 0. What is the ratio of the HFC emissions (in thousand metric tons of CO2 equivalent) in 2000 in Sweden to that in United States?
Offer a very short reply. 0.01. What is the ratio of the HFC emissions (in thousand metric tons of CO2 equivalent) of 2005 in Sweden to that in United States?
Keep it short and to the point. 0.01. What is the ratio of the HFC emissions (in thousand metric tons of CO2 equivalent) of 2008 in Sweden to that in United States?
Give a very brief answer. 0.01. What is the ratio of the HFC emissions (in thousand metric tons of CO2 equivalent) in 2000 in Sweden to that in Venezuela?
Your answer should be compact. 1.21. What is the ratio of the HFC emissions (in thousand metric tons of CO2 equivalent) of 2005 in Sweden to that in Venezuela?
Your response must be concise. 1.53. What is the ratio of the HFC emissions (in thousand metric tons of CO2 equivalent) of 2008 in Sweden to that in Venezuela?
Offer a terse response. 1.15. What is the ratio of the HFC emissions (in thousand metric tons of CO2 equivalent) in 2000 in Switzerland to that in Ukraine?
Your answer should be very brief. 15.51. What is the ratio of the HFC emissions (in thousand metric tons of CO2 equivalent) in 2005 in Switzerland to that in Ukraine?
Your answer should be compact. 7.1. What is the ratio of the HFC emissions (in thousand metric tons of CO2 equivalent) of 2008 in Switzerland to that in Ukraine?
Make the answer very short. 6.35. What is the ratio of the HFC emissions (in thousand metric tons of CO2 equivalent) of 2000 in Switzerland to that in United Kingdom?
Offer a terse response. 0.13. What is the ratio of the HFC emissions (in thousand metric tons of CO2 equivalent) in 2005 in Switzerland to that in United Kingdom?
Your answer should be compact. 0.18. What is the ratio of the HFC emissions (in thousand metric tons of CO2 equivalent) in 2008 in Switzerland to that in United Kingdom?
Keep it short and to the point. 0.18. What is the ratio of the HFC emissions (in thousand metric tons of CO2 equivalent) in 2000 in Switzerland to that in United States?
Your answer should be compact. 0.01. What is the ratio of the HFC emissions (in thousand metric tons of CO2 equivalent) in 2005 in Switzerland to that in United States?
Give a very brief answer. 0.01. What is the ratio of the HFC emissions (in thousand metric tons of CO2 equivalent) of 2008 in Switzerland to that in United States?
Give a very brief answer. 0.01. What is the ratio of the HFC emissions (in thousand metric tons of CO2 equivalent) in 1990 in Switzerland to that in Venezuela?
Your response must be concise. 0. What is the ratio of the HFC emissions (in thousand metric tons of CO2 equivalent) of 2000 in Switzerland to that in Venezuela?
Provide a short and direct response. 1.81. What is the ratio of the HFC emissions (in thousand metric tons of CO2 equivalent) in 2005 in Switzerland to that in Venezuela?
Make the answer very short. 2.19. What is the ratio of the HFC emissions (in thousand metric tons of CO2 equivalent) in 2008 in Switzerland to that in Venezuela?
Your answer should be very brief. 1.62. What is the ratio of the HFC emissions (in thousand metric tons of CO2 equivalent) of 2000 in Ukraine to that in United Kingdom?
Offer a terse response. 0.01. What is the ratio of the HFC emissions (in thousand metric tons of CO2 equivalent) of 2005 in Ukraine to that in United Kingdom?
Provide a short and direct response. 0.03. What is the ratio of the HFC emissions (in thousand metric tons of CO2 equivalent) of 2008 in Ukraine to that in United Kingdom?
Offer a terse response. 0.03. What is the ratio of the HFC emissions (in thousand metric tons of CO2 equivalent) in 1990 in Ukraine to that in United States?
Give a very brief answer. 0. What is the ratio of the HFC emissions (in thousand metric tons of CO2 equivalent) in 2000 in Ukraine to that in United States?
Offer a very short reply. 0. What is the ratio of the HFC emissions (in thousand metric tons of CO2 equivalent) in 2005 in Ukraine to that in United States?
Make the answer very short. 0. What is the ratio of the HFC emissions (in thousand metric tons of CO2 equivalent) of 2008 in Ukraine to that in United States?
Provide a succinct answer. 0. What is the ratio of the HFC emissions (in thousand metric tons of CO2 equivalent) in 1990 in Ukraine to that in Venezuela?
Ensure brevity in your answer.  0. What is the ratio of the HFC emissions (in thousand metric tons of CO2 equivalent) of 2000 in Ukraine to that in Venezuela?
Ensure brevity in your answer.  0.12. What is the ratio of the HFC emissions (in thousand metric tons of CO2 equivalent) of 2005 in Ukraine to that in Venezuela?
Provide a succinct answer. 0.31. What is the ratio of the HFC emissions (in thousand metric tons of CO2 equivalent) of 2008 in Ukraine to that in Venezuela?
Provide a succinct answer. 0.26. What is the ratio of the HFC emissions (in thousand metric tons of CO2 equivalent) of 1990 in United Kingdom to that in United States?
Provide a short and direct response. 0.09. What is the ratio of the HFC emissions (in thousand metric tons of CO2 equivalent) in 2000 in United Kingdom to that in United States?
Your answer should be very brief. 0.06. What is the ratio of the HFC emissions (in thousand metric tons of CO2 equivalent) in 2005 in United Kingdom to that in United States?
Offer a terse response. 0.05. What is the ratio of the HFC emissions (in thousand metric tons of CO2 equivalent) in 2008 in United Kingdom to that in United States?
Your answer should be compact. 0.05. What is the ratio of the HFC emissions (in thousand metric tons of CO2 equivalent) of 1990 in United Kingdom to that in Venezuela?
Provide a succinct answer. 2.65. What is the ratio of the HFC emissions (in thousand metric tons of CO2 equivalent) in 2000 in United Kingdom to that in Venezuela?
Offer a terse response. 13.52. What is the ratio of the HFC emissions (in thousand metric tons of CO2 equivalent) of 2005 in United Kingdom to that in Venezuela?
Keep it short and to the point. 12.25. What is the ratio of the HFC emissions (in thousand metric tons of CO2 equivalent) of 2008 in United Kingdom to that in Venezuela?
Offer a very short reply. 9.02. What is the ratio of the HFC emissions (in thousand metric tons of CO2 equivalent) of 1990 in United States to that in Venezuela?
Offer a very short reply. 29.49. What is the ratio of the HFC emissions (in thousand metric tons of CO2 equivalent) in 2000 in United States to that in Venezuela?
Keep it short and to the point. 240.48. What is the ratio of the HFC emissions (in thousand metric tons of CO2 equivalent) of 2005 in United States to that in Venezuela?
Provide a succinct answer. 252.29. What is the ratio of the HFC emissions (in thousand metric tons of CO2 equivalent) of 2008 in United States to that in Venezuela?
Ensure brevity in your answer.  183.71. What is the difference between the highest and the second highest HFC emissions (in thousand metric tons of CO2 equivalent) in 1990?
Make the answer very short. 2.66e+04. What is the difference between the highest and the second highest HFC emissions (in thousand metric tons of CO2 equivalent) of 2000?
Your response must be concise. 1.06e+05. What is the difference between the highest and the second highest HFC emissions (in thousand metric tons of CO2 equivalent) in 2005?
Provide a succinct answer. 1.77e+05. What is the difference between the highest and the second highest HFC emissions (in thousand metric tons of CO2 equivalent) in 2008?
Your answer should be compact. 2.28e+05. What is the difference between the highest and the lowest HFC emissions (in thousand metric tons of CO2 equivalent) in 1990?
Offer a terse response. 2.92e+04. What is the difference between the highest and the lowest HFC emissions (in thousand metric tons of CO2 equivalent) in 2000?
Offer a very short reply. 1.13e+05. What is the difference between the highest and the lowest HFC emissions (in thousand metric tons of CO2 equivalent) of 2005?
Give a very brief answer. 1.86e+05. What is the difference between the highest and the lowest HFC emissions (in thousand metric tons of CO2 equivalent) in 2008?
Provide a short and direct response. 2.40e+05. 